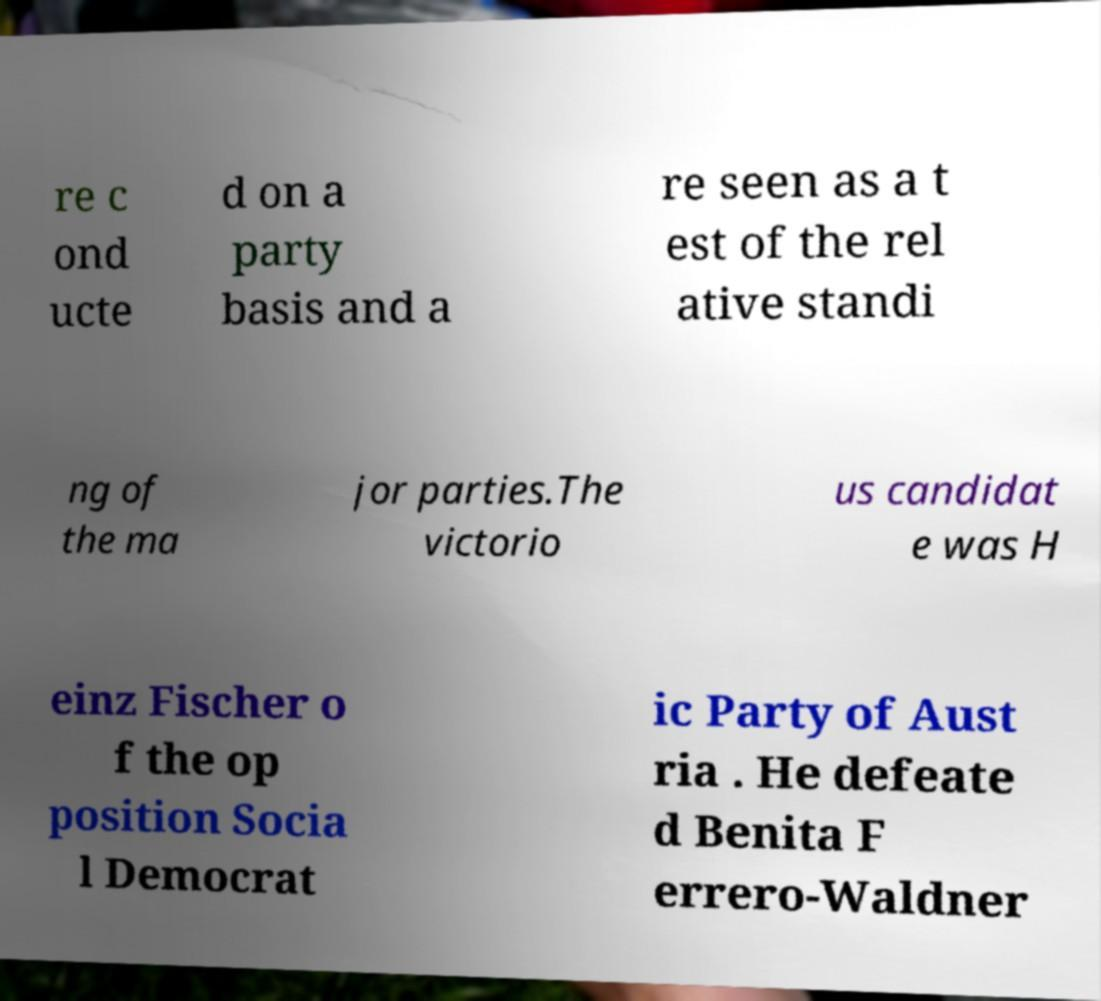What messages or text are displayed in this image? I need them in a readable, typed format. re c ond ucte d on a party basis and a re seen as a t est of the rel ative standi ng of the ma jor parties.The victorio us candidat e was H einz Fischer o f the op position Socia l Democrat ic Party of Aust ria . He defeate d Benita F errero-Waldner 